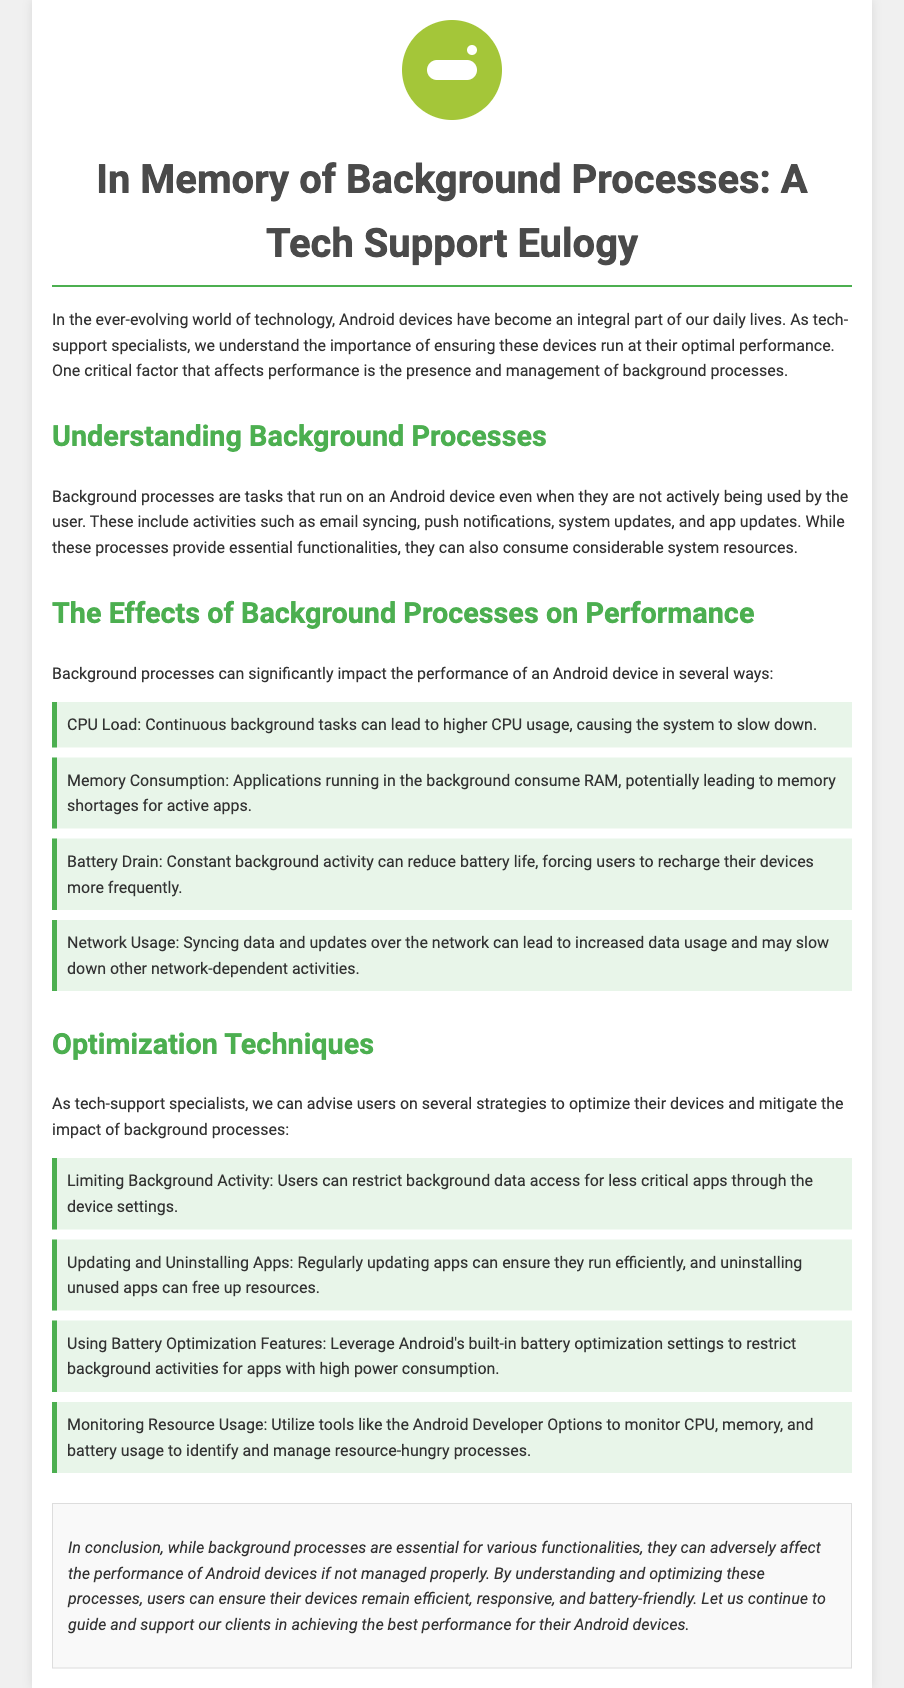What is the main topic of the eulogy? The eulogy focuses on the impact of background processes on the performance of Android devices and their management.
Answer: Background processes What are two examples of background processes mentioned? Email syncing and push notifications are examples of background processes that run on an Android device.
Answer: Email syncing, push notifications How many ways are listed on how background processes can affect performance? The document mentions four specific ways that background processes can impact performance.
Answer: Four What is one optimization technique mentioned for improving Android performance? The document suggests restricting background data access for less critical apps as an optimization technique.
Answer: Limiting background activity What impact can background processes have on battery life? Continuous background activity can reduce battery life and require more frequent recharges.
Answer: Reduce battery life What should users regularly do to ensure apps run efficiently? Regularly updating apps is recommended for ensuring they run efficiently.
Answer: Update apps What color is used for the section headings in the document? The color used for section headings, like h2, is a shade of green, specifically #4CAF50.
Answer: Green What type of document is this? The document is styled as a memorial or tribute to background processes related to Android performance.
Answer: Eulogy 